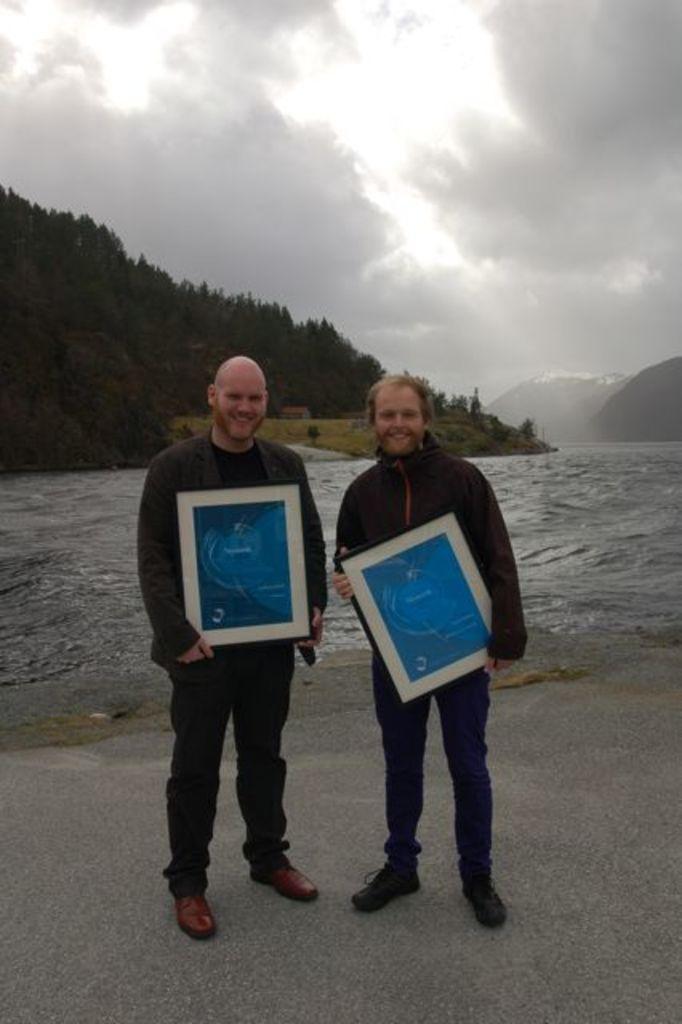Please provide a concise description of this image. In this image there are two people holding frames and standing in front of water, there are few mountains covered with trees, few mountains are covered with snow, grass and some clouds in the sky. 